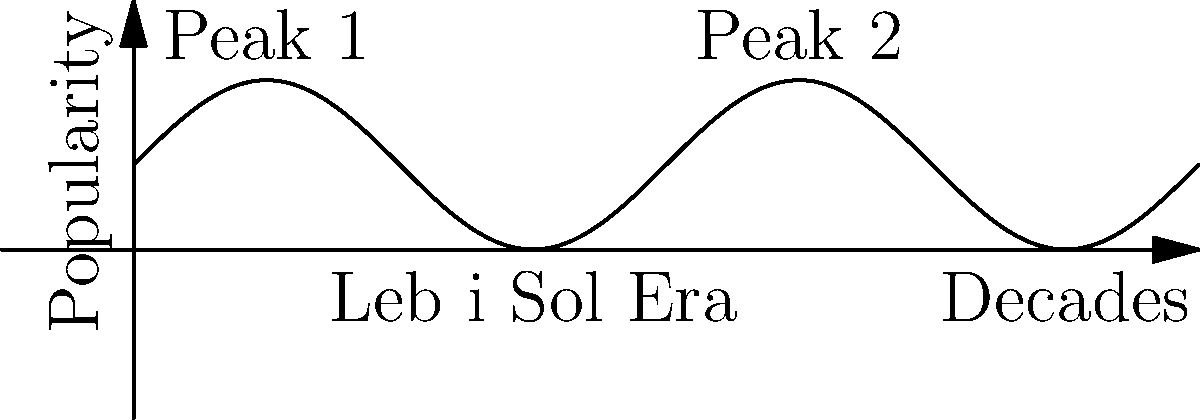The unit circle can be used to model the cyclical nature of music trends over decades. If each complete revolution represents 40 years, and Leb i Sol's peak popularity occurred in the 1980s, in which decade will a similar musical style likely experience a resurgence, assuming the trend follows a sinusoidal pattern? Let's approach this step-by-step:

1) In the unit circle, one complete revolution is $2\pi$ radians.
2) We're told that one revolution represents 40 years.
3) So, $2\pi$ radians = 40 years, or $\pi$ radians = 20 years.
4) Leb i Sol's peak was in the 1980s. Let's set this as our reference point at $0$ radians.
5) To find the next peak, we need to go forward by $2\pi$ radians.
6) $2\pi$ radians = 40 years
7) So, the next peak would occur 40 years after the 1980s.
8) 1980s + 40 years = 2020s

Therefore, assuming the cyclical nature of music trends follows this sinusoidal pattern, a similar musical style to Leb i Sol would likely experience a resurgence in the 2020s.
Answer: 2020s 